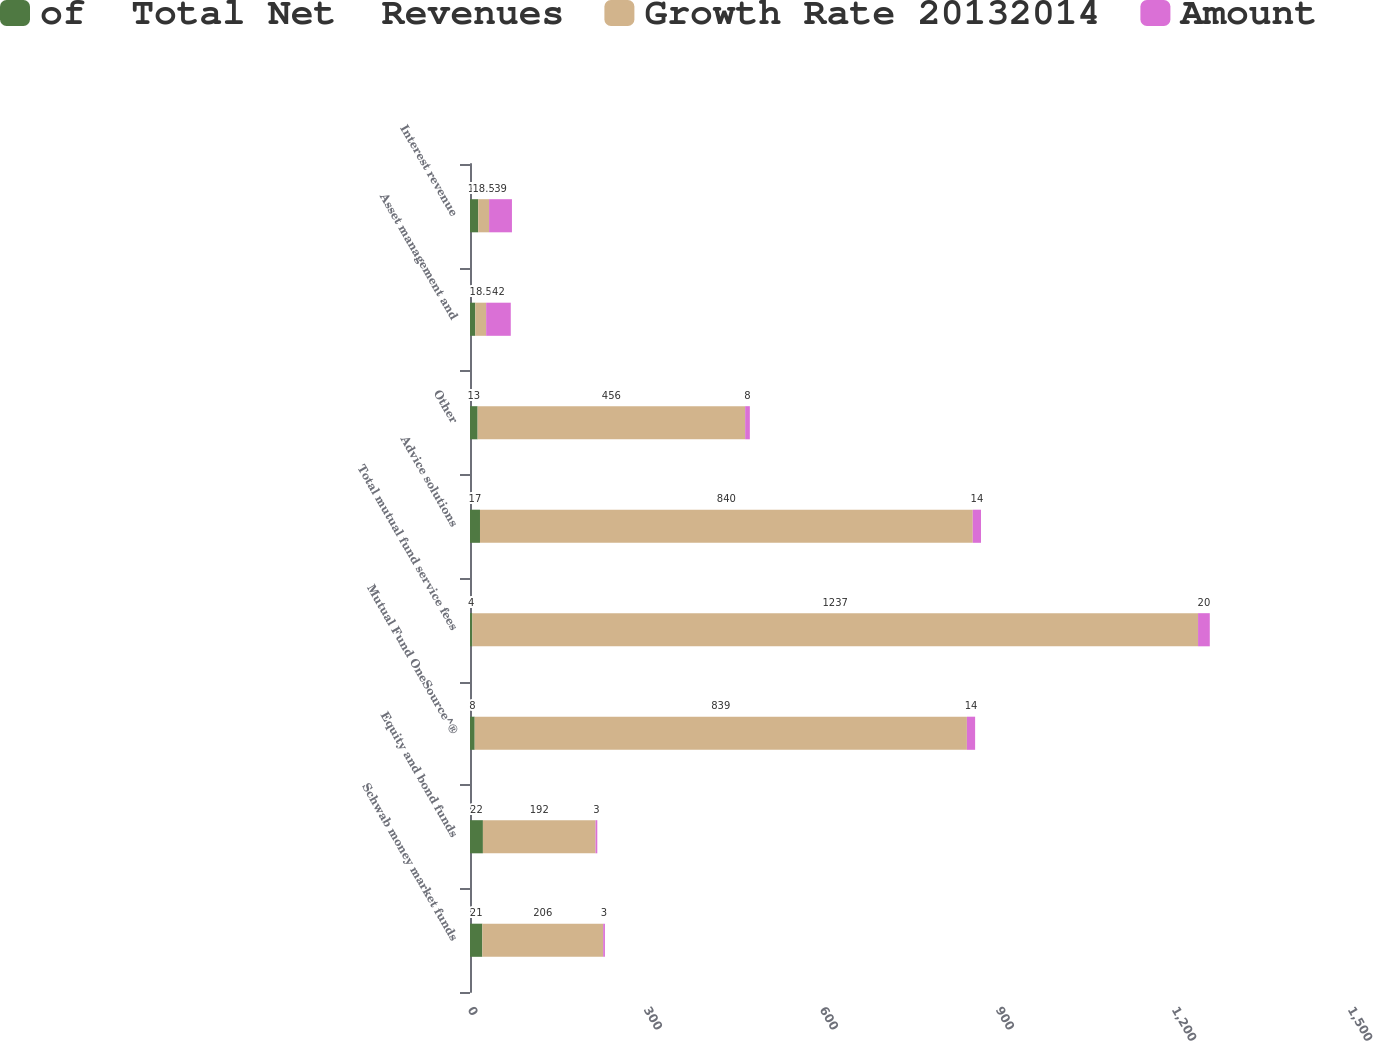Convert chart to OTSL. <chart><loc_0><loc_0><loc_500><loc_500><stacked_bar_chart><ecel><fcel>Schwab money market funds<fcel>Equity and bond funds<fcel>Mutual Fund OneSource^®<fcel>Total mutual fund service fees<fcel>Advice solutions<fcel>Other<fcel>Asset management and<fcel>Interest revenue<nl><fcel>of  Total Net  Revenues<fcel>21<fcel>22<fcel>8<fcel>4<fcel>17<fcel>13<fcel>9<fcel>14<nl><fcel>Growth Rate 20132014<fcel>206<fcel>192<fcel>839<fcel>1237<fcel>840<fcel>456<fcel>18.5<fcel>18.5<nl><fcel>Amount<fcel>3<fcel>3<fcel>14<fcel>20<fcel>14<fcel>8<fcel>42<fcel>39<nl></chart> 